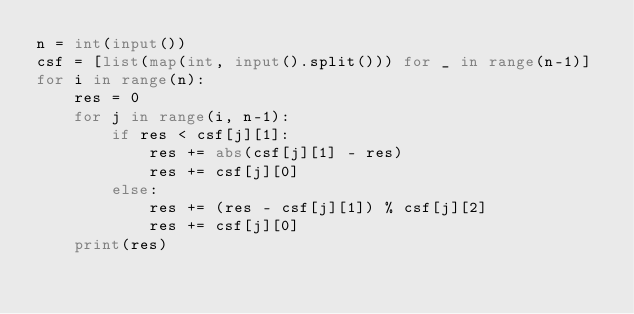<code> <loc_0><loc_0><loc_500><loc_500><_Python_>n = int(input())
csf = [list(map(int, input().split())) for _ in range(n-1)]
for i in range(n):
    res = 0
    for j in range(i, n-1):
        if res < csf[j][1]:
            res += abs(csf[j][1] - res)
            res += csf[j][0]
        else:
            res += (res - csf[j][1]) % csf[j][2]
            res += csf[j][0]
    print(res)
</code> 